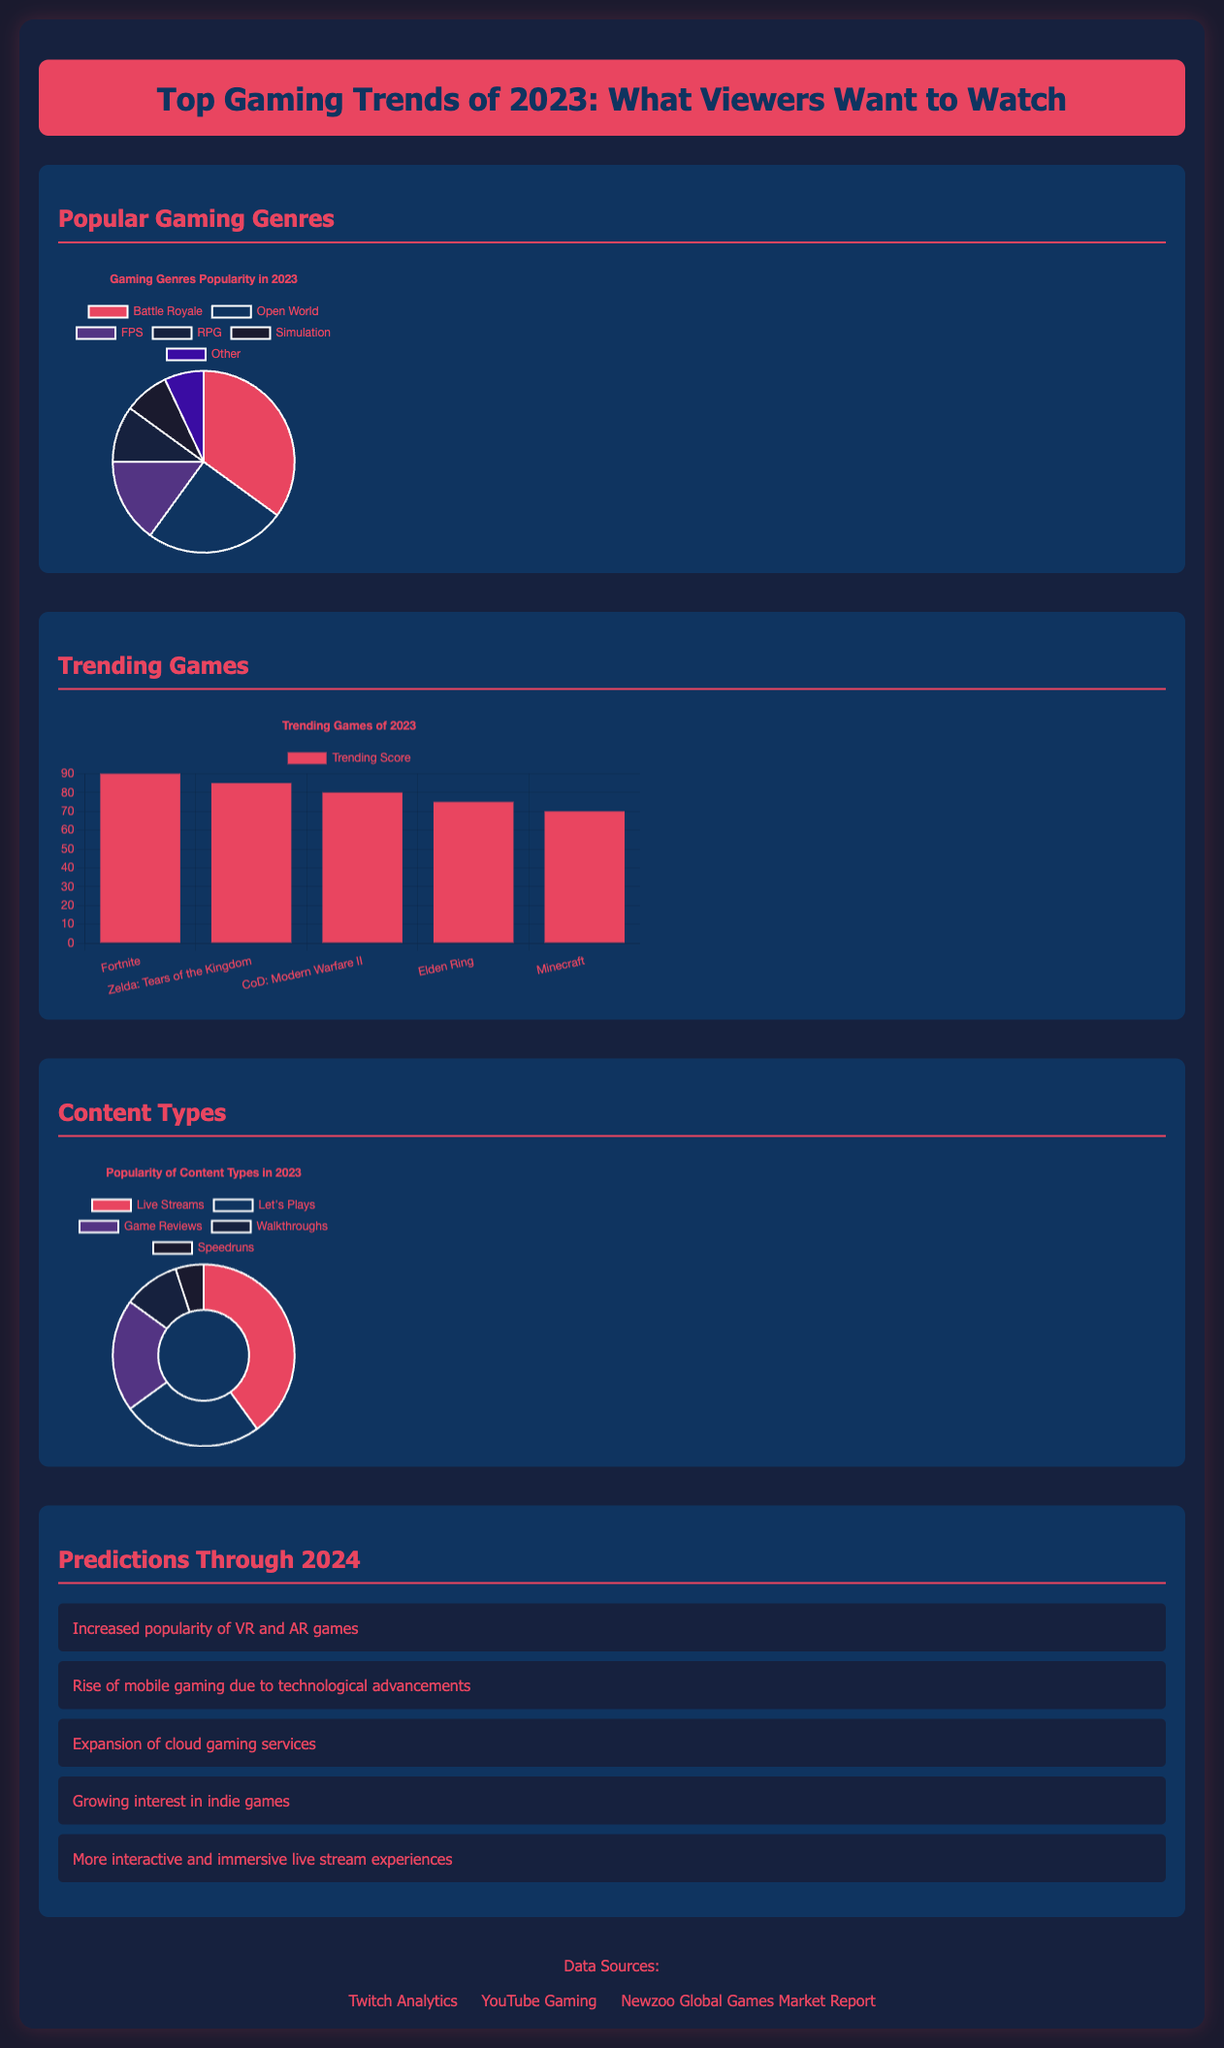What is the most popular gaming genre in 2023? The most popular gaming genre is found in the pie chart titled "Gaming Genres Popularity in 2023", indicating Battle Royale leads with 35%.
Answer: Battle Royale How many games are listed as trending in the infographic? The infographic highlights five trending games in the "Trending Games of 2023" section.
Answer: Five What is the trending score of Fortnite? The trending score is specified in the bar chart for each game, showing Fortnite has a score of 90.
Answer: 90 Which content type is the most popular in 2023? The most popular content type can be identified in the doughnut chart, which shows that Live Streams dominate with 40%.
Answer: Live Streams What will be the growing interest in indie games indicate by 2024? The prediction list provides insights for future trends, including the growing interest in indie games.
Answer: Growing interest in indie games What is the color code for the FPS genre in the chart? The color corresponding to the FPS genre is indicated in the color legend of the pie chart.
Answer: #533483 How many predictions are made through 2024? The predictions made in the infographic are clearly listed, totaling five.
Answer: Five What percentage of viewers prefer Simulation games according to the Pie Chart? The percentage for Simulation games is included in the pie chart, showing a specific share in the genre category.
Answer: 8% 